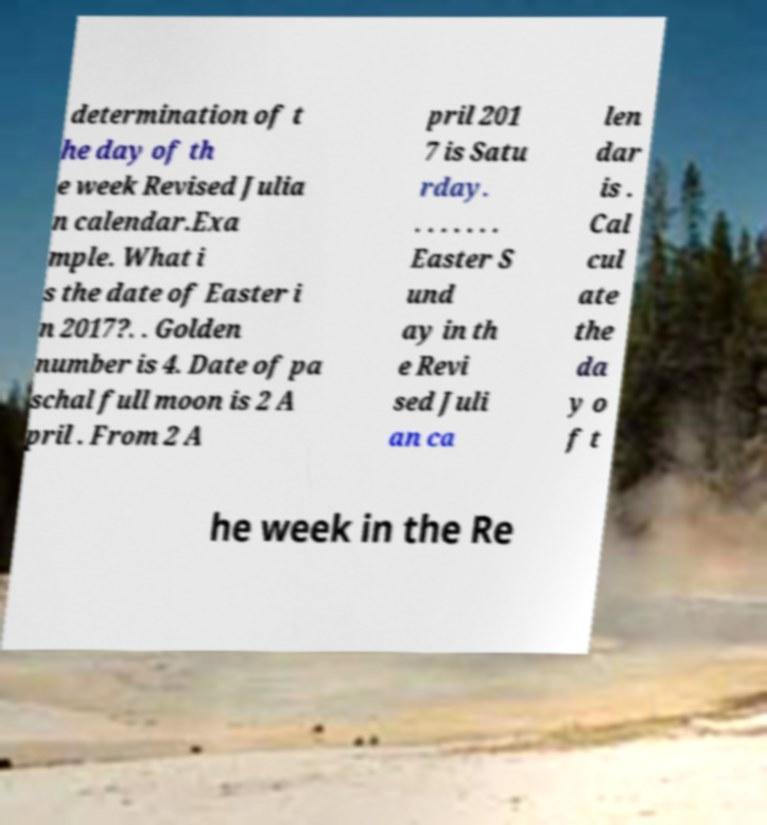Can you accurately transcribe the text from the provided image for me? determination of t he day of th e week Revised Julia n calendar.Exa mple. What i s the date of Easter i n 2017?. . Golden number is 4. Date of pa schal full moon is 2 A pril . From 2 A pril 201 7 is Satu rday. . . . . . . . Easter S und ay in th e Revi sed Juli an ca len dar is . Cal cul ate the da y o f t he week in the Re 